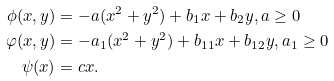Convert formula to latex. <formula><loc_0><loc_0><loc_500><loc_500>\phi ( x , y ) & = - a ( x ^ { 2 } + y ^ { 2 } ) + b _ { 1 } x + b _ { 2 } y , a \geq 0 \\ \varphi ( x , y ) & = - a _ { 1 } ( x ^ { 2 } + y ^ { 2 } ) + b _ { 1 1 } x + b _ { 1 2 } y , a _ { 1 } \geq 0 \\ \psi ( x ) & = c x .</formula> 